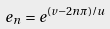Convert formula to latex. <formula><loc_0><loc_0><loc_500><loc_500>e _ { n } = e ^ { ( v - 2 n \pi ) / u }</formula> 